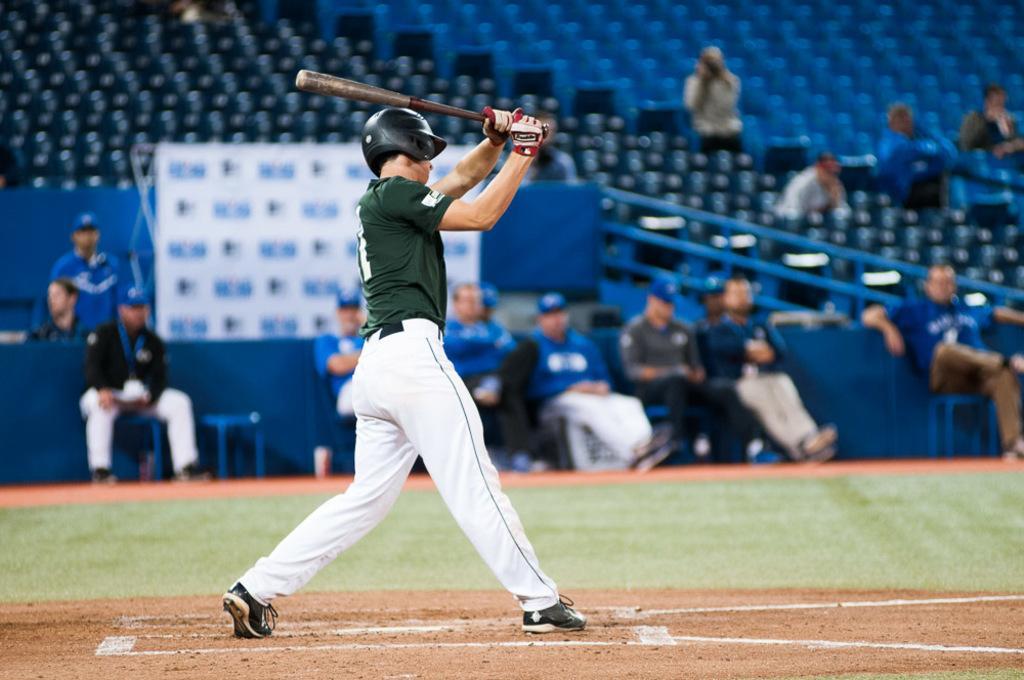Can you describe this image briefly? This image is taken in a stadium. In this image there is a person standing and he is holding a baseball bat. In the background there are few spectators. 